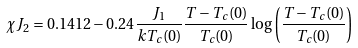<formula> <loc_0><loc_0><loc_500><loc_500>\chi J _ { 2 } = 0 . 1 4 1 2 - 0 . 2 4 \frac { J _ { 1 } } { k T _ { c } ( 0 ) } \frac { T - T _ { c } ( 0 ) } { T _ { c } ( 0 ) } \log \left ( \frac { T - T _ { c } ( 0 ) } { T _ { c } ( 0 ) } \right )</formula> 